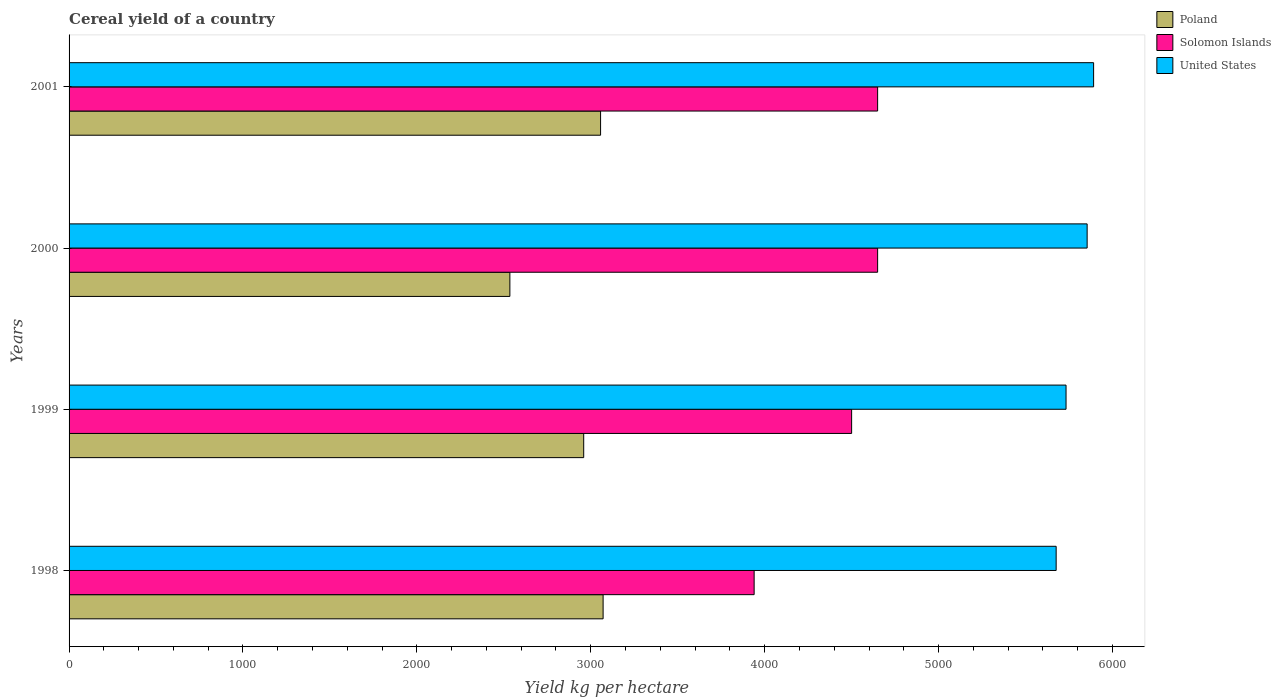How many groups of bars are there?
Make the answer very short. 4. Are the number of bars on each tick of the Y-axis equal?
Your answer should be compact. Yes. How many bars are there on the 3rd tick from the bottom?
Your answer should be compact. 3. In how many cases, is the number of bars for a given year not equal to the number of legend labels?
Provide a short and direct response. 0. What is the total cereal yield in Poland in 1998?
Provide a short and direct response. 3070.96. Across all years, what is the maximum total cereal yield in Poland?
Your answer should be very brief. 3070.96. Across all years, what is the minimum total cereal yield in Poland?
Your response must be concise. 2534.78. What is the total total cereal yield in United States in the graph?
Offer a very short reply. 2.32e+04. What is the difference between the total cereal yield in Poland in 2000 and that in 2001?
Provide a succinct answer. -521.62. What is the difference between the total cereal yield in Poland in 2000 and the total cereal yield in United States in 1999?
Make the answer very short. -3198.21. What is the average total cereal yield in Solomon Islands per year?
Provide a succinct answer. 4434.62. In the year 1999, what is the difference between the total cereal yield in Poland and total cereal yield in United States?
Offer a very short reply. -2773.62. In how many years, is the total cereal yield in Poland greater than 5200 kg per hectare?
Offer a terse response. 0. What is the ratio of the total cereal yield in Solomon Islands in 1998 to that in 2001?
Offer a terse response. 0.85. Is the difference between the total cereal yield in Poland in 1998 and 2000 greater than the difference between the total cereal yield in United States in 1998 and 2000?
Your response must be concise. Yes. What is the difference between the highest and the second highest total cereal yield in Solomon Islands?
Your answer should be compact. 0.02. What is the difference between the highest and the lowest total cereal yield in Solomon Islands?
Provide a short and direct response. 710.16. Is the sum of the total cereal yield in Solomon Islands in 1999 and 2000 greater than the maximum total cereal yield in United States across all years?
Your answer should be very brief. Yes. What does the 1st bar from the top in 1999 represents?
Provide a succinct answer. United States. What does the 3rd bar from the bottom in 2000 represents?
Give a very brief answer. United States. Are all the bars in the graph horizontal?
Your answer should be very brief. Yes. How many years are there in the graph?
Keep it short and to the point. 4. What is the difference between two consecutive major ticks on the X-axis?
Offer a terse response. 1000. Are the values on the major ticks of X-axis written in scientific E-notation?
Ensure brevity in your answer.  No. Does the graph contain any zero values?
Your answer should be compact. No. Does the graph contain grids?
Your answer should be compact. No. How many legend labels are there?
Your response must be concise. 3. What is the title of the graph?
Make the answer very short. Cereal yield of a country. Does "Niger" appear as one of the legend labels in the graph?
Your response must be concise. No. What is the label or title of the X-axis?
Offer a very short reply. Yield kg per hectare. What is the label or title of the Y-axis?
Make the answer very short. Years. What is the Yield kg per hectare of Poland in 1998?
Your answer should be compact. 3070.96. What is the Yield kg per hectare in Solomon Islands in 1998?
Make the answer very short. 3939.39. What is the Yield kg per hectare of United States in 1998?
Keep it short and to the point. 5676.14. What is the Yield kg per hectare in Poland in 1999?
Your answer should be compact. 2959.36. What is the Yield kg per hectare in Solomon Islands in 1999?
Provide a succinct answer. 4500. What is the Yield kg per hectare in United States in 1999?
Provide a succinct answer. 5732.99. What is the Yield kg per hectare in Poland in 2000?
Give a very brief answer. 2534.78. What is the Yield kg per hectare in Solomon Islands in 2000?
Give a very brief answer. 4649.54. What is the Yield kg per hectare in United States in 2000?
Offer a terse response. 5854.28. What is the Yield kg per hectare of Poland in 2001?
Give a very brief answer. 3056.4. What is the Yield kg per hectare in Solomon Islands in 2001?
Give a very brief answer. 4649.55. What is the Yield kg per hectare of United States in 2001?
Give a very brief answer. 5891.52. Across all years, what is the maximum Yield kg per hectare of Poland?
Offer a very short reply. 3070.96. Across all years, what is the maximum Yield kg per hectare in Solomon Islands?
Your answer should be very brief. 4649.55. Across all years, what is the maximum Yield kg per hectare in United States?
Keep it short and to the point. 5891.52. Across all years, what is the minimum Yield kg per hectare of Poland?
Your answer should be compact. 2534.78. Across all years, what is the minimum Yield kg per hectare in Solomon Islands?
Provide a short and direct response. 3939.39. Across all years, what is the minimum Yield kg per hectare in United States?
Your answer should be compact. 5676.14. What is the total Yield kg per hectare of Poland in the graph?
Keep it short and to the point. 1.16e+04. What is the total Yield kg per hectare in Solomon Islands in the graph?
Your response must be concise. 1.77e+04. What is the total Yield kg per hectare of United States in the graph?
Your answer should be compact. 2.32e+04. What is the difference between the Yield kg per hectare in Poland in 1998 and that in 1999?
Ensure brevity in your answer.  111.6. What is the difference between the Yield kg per hectare of Solomon Islands in 1998 and that in 1999?
Keep it short and to the point. -560.61. What is the difference between the Yield kg per hectare in United States in 1998 and that in 1999?
Provide a short and direct response. -56.85. What is the difference between the Yield kg per hectare in Poland in 1998 and that in 2000?
Provide a succinct answer. 536.18. What is the difference between the Yield kg per hectare of Solomon Islands in 1998 and that in 2000?
Your response must be concise. -710.14. What is the difference between the Yield kg per hectare in United States in 1998 and that in 2000?
Ensure brevity in your answer.  -178.15. What is the difference between the Yield kg per hectare of Poland in 1998 and that in 2001?
Ensure brevity in your answer.  14.56. What is the difference between the Yield kg per hectare in Solomon Islands in 1998 and that in 2001?
Your response must be concise. -710.16. What is the difference between the Yield kg per hectare in United States in 1998 and that in 2001?
Provide a succinct answer. -215.38. What is the difference between the Yield kg per hectare of Poland in 1999 and that in 2000?
Provide a succinct answer. 424.58. What is the difference between the Yield kg per hectare of Solomon Islands in 1999 and that in 2000?
Make the answer very short. -149.54. What is the difference between the Yield kg per hectare of United States in 1999 and that in 2000?
Ensure brevity in your answer.  -121.3. What is the difference between the Yield kg per hectare of Poland in 1999 and that in 2001?
Ensure brevity in your answer.  -97.04. What is the difference between the Yield kg per hectare of Solomon Islands in 1999 and that in 2001?
Your response must be concise. -149.55. What is the difference between the Yield kg per hectare in United States in 1999 and that in 2001?
Give a very brief answer. -158.53. What is the difference between the Yield kg per hectare of Poland in 2000 and that in 2001?
Ensure brevity in your answer.  -521.62. What is the difference between the Yield kg per hectare of Solomon Islands in 2000 and that in 2001?
Keep it short and to the point. -0.02. What is the difference between the Yield kg per hectare of United States in 2000 and that in 2001?
Offer a very short reply. -37.24. What is the difference between the Yield kg per hectare of Poland in 1998 and the Yield kg per hectare of Solomon Islands in 1999?
Offer a terse response. -1429.04. What is the difference between the Yield kg per hectare in Poland in 1998 and the Yield kg per hectare in United States in 1999?
Ensure brevity in your answer.  -2662.02. What is the difference between the Yield kg per hectare in Solomon Islands in 1998 and the Yield kg per hectare in United States in 1999?
Your answer should be very brief. -1793.59. What is the difference between the Yield kg per hectare of Poland in 1998 and the Yield kg per hectare of Solomon Islands in 2000?
Your response must be concise. -1578.58. What is the difference between the Yield kg per hectare in Poland in 1998 and the Yield kg per hectare in United States in 2000?
Offer a terse response. -2783.32. What is the difference between the Yield kg per hectare of Solomon Islands in 1998 and the Yield kg per hectare of United States in 2000?
Your answer should be very brief. -1914.89. What is the difference between the Yield kg per hectare of Poland in 1998 and the Yield kg per hectare of Solomon Islands in 2001?
Your response must be concise. -1578.59. What is the difference between the Yield kg per hectare in Poland in 1998 and the Yield kg per hectare in United States in 2001?
Make the answer very short. -2820.56. What is the difference between the Yield kg per hectare of Solomon Islands in 1998 and the Yield kg per hectare of United States in 2001?
Provide a succinct answer. -1952.13. What is the difference between the Yield kg per hectare in Poland in 1999 and the Yield kg per hectare in Solomon Islands in 2000?
Offer a very short reply. -1690.17. What is the difference between the Yield kg per hectare in Poland in 1999 and the Yield kg per hectare in United States in 2000?
Make the answer very short. -2894.92. What is the difference between the Yield kg per hectare in Solomon Islands in 1999 and the Yield kg per hectare in United States in 2000?
Your answer should be compact. -1354.28. What is the difference between the Yield kg per hectare of Poland in 1999 and the Yield kg per hectare of Solomon Islands in 2001?
Provide a succinct answer. -1690.19. What is the difference between the Yield kg per hectare of Poland in 1999 and the Yield kg per hectare of United States in 2001?
Offer a very short reply. -2932.16. What is the difference between the Yield kg per hectare in Solomon Islands in 1999 and the Yield kg per hectare in United States in 2001?
Keep it short and to the point. -1391.52. What is the difference between the Yield kg per hectare of Poland in 2000 and the Yield kg per hectare of Solomon Islands in 2001?
Your answer should be very brief. -2114.77. What is the difference between the Yield kg per hectare in Poland in 2000 and the Yield kg per hectare in United States in 2001?
Offer a terse response. -3356.74. What is the difference between the Yield kg per hectare in Solomon Islands in 2000 and the Yield kg per hectare in United States in 2001?
Make the answer very short. -1241.98. What is the average Yield kg per hectare of Poland per year?
Offer a terse response. 2905.38. What is the average Yield kg per hectare of Solomon Islands per year?
Your answer should be compact. 4434.62. What is the average Yield kg per hectare in United States per year?
Offer a terse response. 5788.73. In the year 1998, what is the difference between the Yield kg per hectare in Poland and Yield kg per hectare in Solomon Islands?
Keep it short and to the point. -868.43. In the year 1998, what is the difference between the Yield kg per hectare in Poland and Yield kg per hectare in United States?
Provide a short and direct response. -2605.17. In the year 1998, what is the difference between the Yield kg per hectare in Solomon Islands and Yield kg per hectare in United States?
Provide a succinct answer. -1736.74. In the year 1999, what is the difference between the Yield kg per hectare of Poland and Yield kg per hectare of Solomon Islands?
Provide a short and direct response. -1540.64. In the year 1999, what is the difference between the Yield kg per hectare in Poland and Yield kg per hectare in United States?
Your answer should be very brief. -2773.62. In the year 1999, what is the difference between the Yield kg per hectare in Solomon Islands and Yield kg per hectare in United States?
Offer a very short reply. -1232.99. In the year 2000, what is the difference between the Yield kg per hectare of Poland and Yield kg per hectare of Solomon Islands?
Give a very brief answer. -2114.76. In the year 2000, what is the difference between the Yield kg per hectare in Poland and Yield kg per hectare in United States?
Make the answer very short. -3319.5. In the year 2000, what is the difference between the Yield kg per hectare of Solomon Islands and Yield kg per hectare of United States?
Ensure brevity in your answer.  -1204.74. In the year 2001, what is the difference between the Yield kg per hectare of Poland and Yield kg per hectare of Solomon Islands?
Offer a very short reply. -1593.15. In the year 2001, what is the difference between the Yield kg per hectare of Poland and Yield kg per hectare of United States?
Your response must be concise. -2835.12. In the year 2001, what is the difference between the Yield kg per hectare of Solomon Islands and Yield kg per hectare of United States?
Ensure brevity in your answer.  -1241.97. What is the ratio of the Yield kg per hectare in Poland in 1998 to that in 1999?
Give a very brief answer. 1.04. What is the ratio of the Yield kg per hectare of Solomon Islands in 1998 to that in 1999?
Your response must be concise. 0.88. What is the ratio of the Yield kg per hectare in Poland in 1998 to that in 2000?
Offer a terse response. 1.21. What is the ratio of the Yield kg per hectare in Solomon Islands in 1998 to that in 2000?
Provide a short and direct response. 0.85. What is the ratio of the Yield kg per hectare in United States in 1998 to that in 2000?
Provide a succinct answer. 0.97. What is the ratio of the Yield kg per hectare in Solomon Islands in 1998 to that in 2001?
Provide a succinct answer. 0.85. What is the ratio of the Yield kg per hectare in United States in 1998 to that in 2001?
Give a very brief answer. 0.96. What is the ratio of the Yield kg per hectare in Poland in 1999 to that in 2000?
Provide a succinct answer. 1.17. What is the ratio of the Yield kg per hectare of Solomon Islands in 1999 to that in 2000?
Offer a very short reply. 0.97. What is the ratio of the Yield kg per hectare of United States in 1999 to that in 2000?
Ensure brevity in your answer.  0.98. What is the ratio of the Yield kg per hectare of Poland in 1999 to that in 2001?
Provide a succinct answer. 0.97. What is the ratio of the Yield kg per hectare of Solomon Islands in 1999 to that in 2001?
Provide a succinct answer. 0.97. What is the ratio of the Yield kg per hectare in United States in 1999 to that in 2001?
Offer a very short reply. 0.97. What is the ratio of the Yield kg per hectare of Poland in 2000 to that in 2001?
Your answer should be compact. 0.83. What is the ratio of the Yield kg per hectare in Solomon Islands in 2000 to that in 2001?
Your answer should be compact. 1. What is the ratio of the Yield kg per hectare of United States in 2000 to that in 2001?
Make the answer very short. 0.99. What is the difference between the highest and the second highest Yield kg per hectare in Poland?
Your response must be concise. 14.56. What is the difference between the highest and the second highest Yield kg per hectare in Solomon Islands?
Provide a short and direct response. 0.02. What is the difference between the highest and the second highest Yield kg per hectare in United States?
Your response must be concise. 37.24. What is the difference between the highest and the lowest Yield kg per hectare of Poland?
Provide a succinct answer. 536.18. What is the difference between the highest and the lowest Yield kg per hectare in Solomon Islands?
Give a very brief answer. 710.16. What is the difference between the highest and the lowest Yield kg per hectare of United States?
Your answer should be very brief. 215.38. 